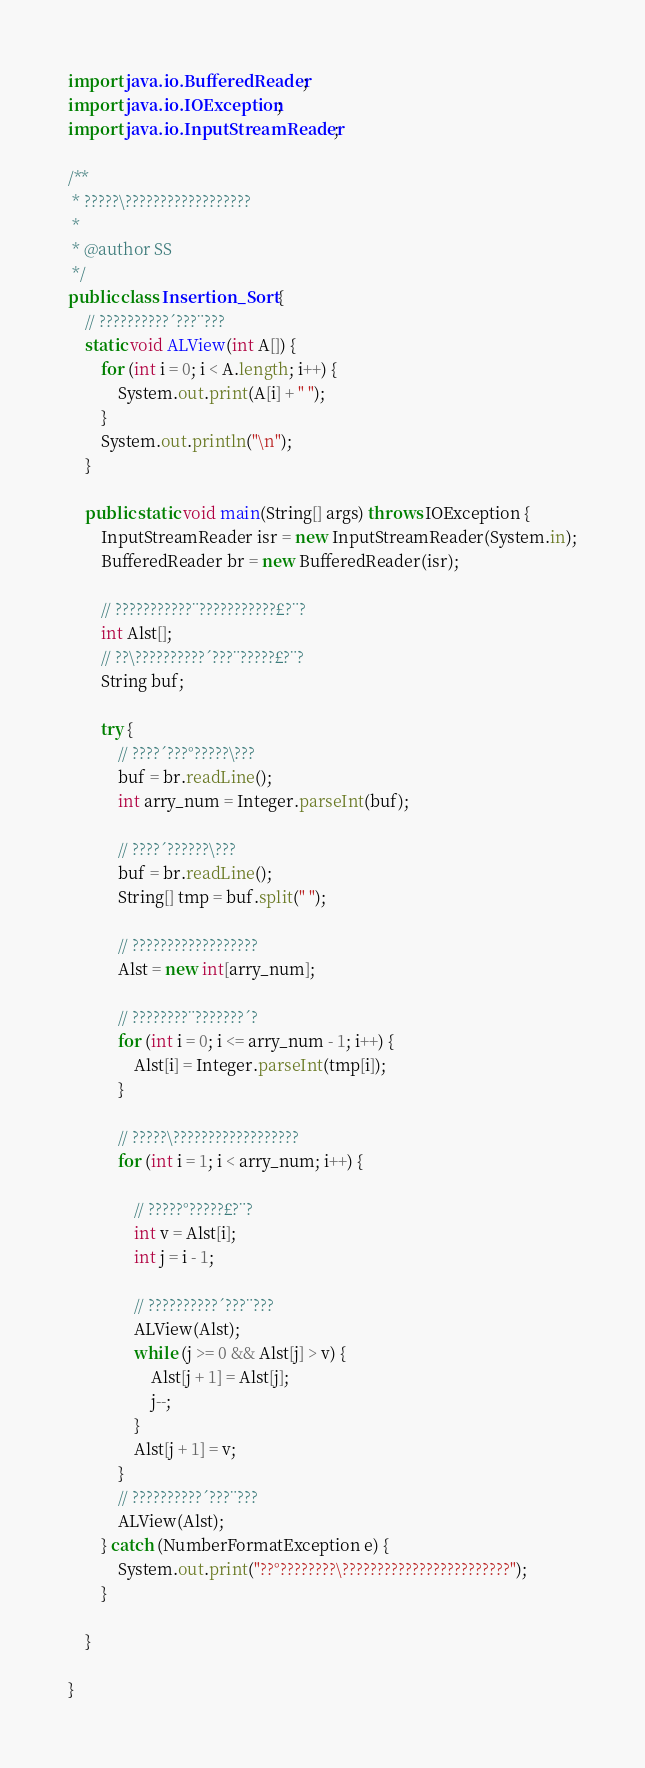<code> <loc_0><loc_0><loc_500><loc_500><_Java_>import java.io.BufferedReader;
import java.io.IOException;
import java.io.InputStreamReader;

/**
 * ?????\??????????????????
 *
 * @author SS
 */
public class Insertion_Sort {
	// ??????????´???¨???
	static void ALView(int A[]) {
		for (int i = 0; i < A.length; i++) {
			System.out.print(A[i] + " ");
		}
		System.out.println("\n");
	}

	public static void main(String[] args) throws IOException {
		InputStreamReader isr = new InputStreamReader(System.in);
		BufferedReader br = new BufferedReader(isr);

		// ???????????¨???????????£?¨?
		int Alst[];
		// ??\??????????´???¨?????£?¨?
		String buf;

		try {
			// ????´???°?????\???
			buf = br.readLine();
			int arry_num = Integer.parseInt(buf);

			// ????´??????\???
			buf = br.readLine();
			String[] tmp = buf.split(" ");

			// ??????????????????
			Alst = new int[arry_num];

			// ????????¨???????´?
			for (int i = 0; i <= arry_num - 1; i++) {
				Alst[i] = Integer.parseInt(tmp[i]);
			}

			// ?????\??????????????????
			for (int i = 1; i < arry_num; i++) {

				// ?????°?????£?¨?
				int v = Alst[i];
				int j = i - 1;

				// ??????????´???¨???
				ALView(Alst);
				while (j >= 0 && Alst[j] > v) {
					Alst[j + 1] = Alst[j];
					j--;
				}
				Alst[j + 1] = v;
			}
			// ??????????´???¨???
			ALView(Alst);
		} catch (NumberFormatException e) {
			System.out.print("??°????????\????????????????????????");
		}

	}

}</code> 